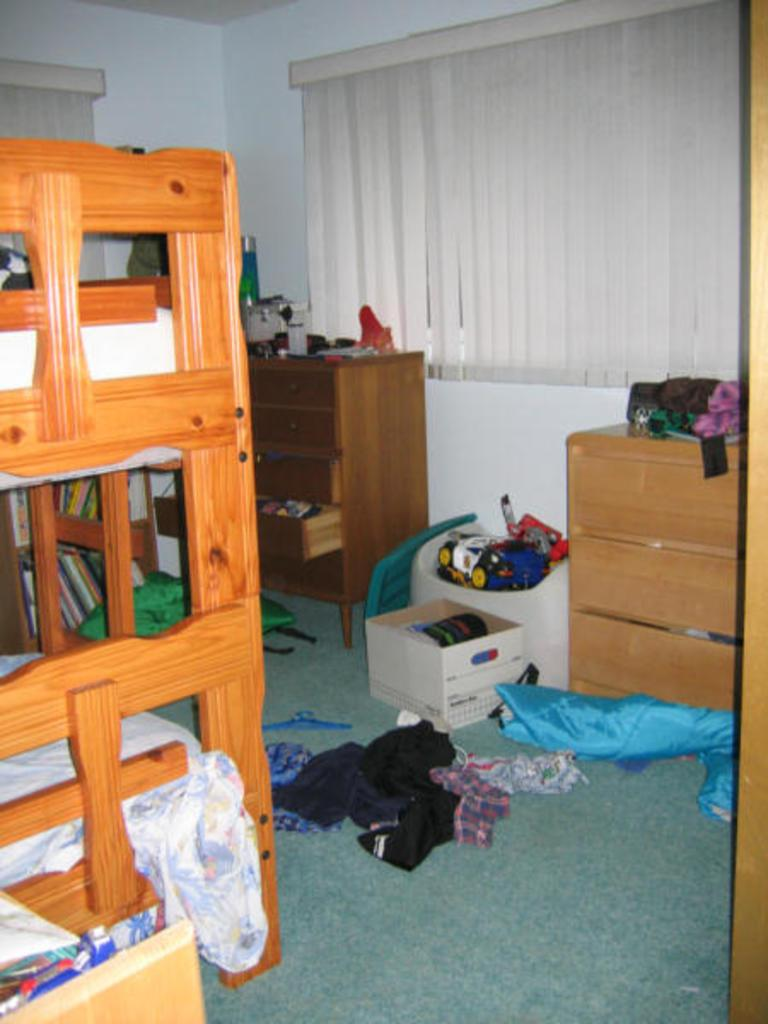What type of bed is in the room? There is a double Decker bed in the room. What piece of furniture is typically used for studying or working? There is a desk in the room. What other piece of furniture is present in the room? There is a table in the room. What can be seen on the floor in the room? Clothes and other things are on the floor. What type of straw is being used to treat the wound on the floor? There is no straw or wound present in the image. How many pins are holding the clothes together on the floor? There are no pins mentioned in the image, and the clothes are not described as being held together. 